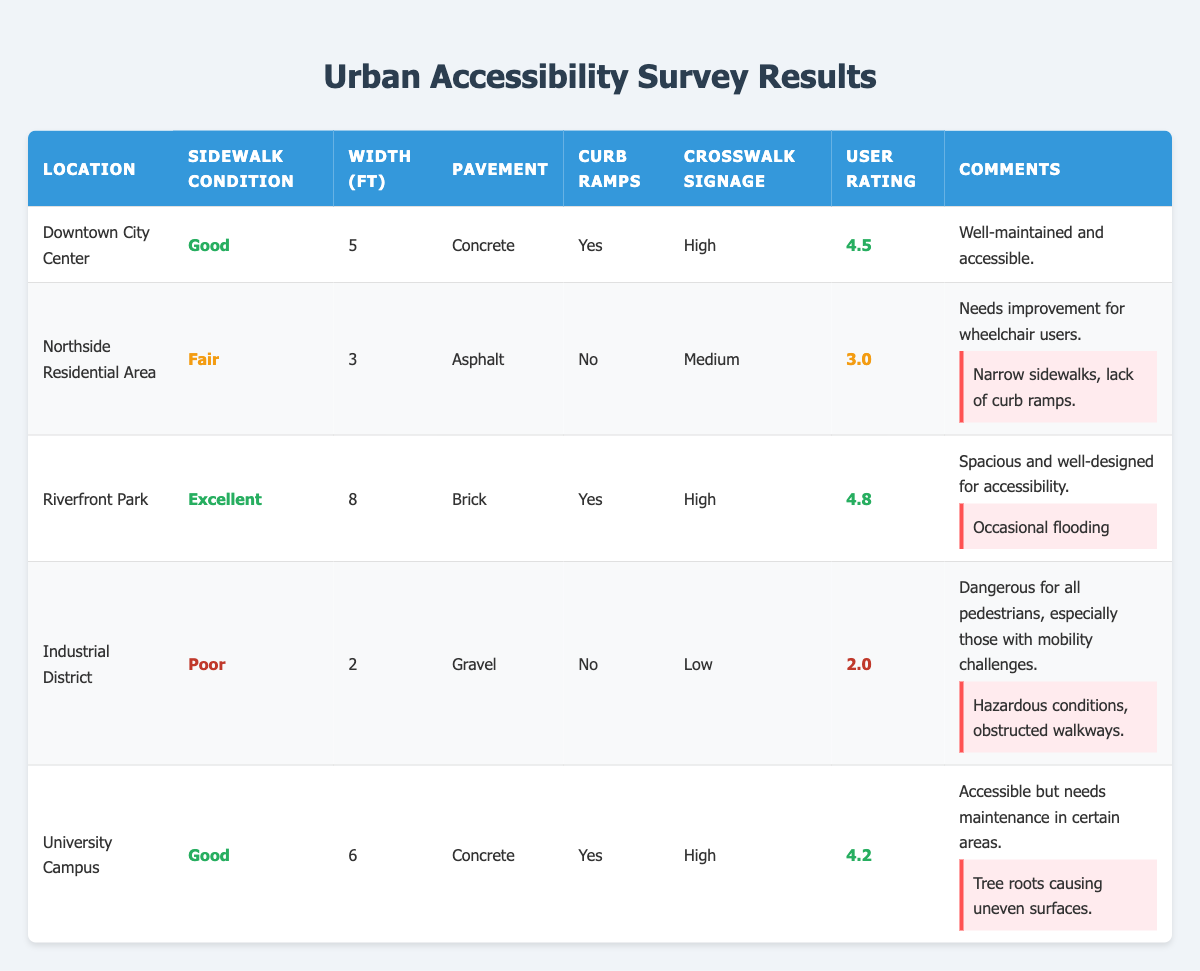What is the average user rating for the Riverfront Park? The user rating for Riverfront Park is listed in the table as 4.8. Since it is a single data point, the average user rating for that location is simply 4.8.
Answer: 4.8 Which location has the widest average sidewalk? The table shows the average widths for each location: Downtown City Center has 5 ft, Northside Residential Area has 3 ft, Riverfront Park has 8 ft, Industrial District has 2 ft, and University Campus has 6 ft. The maximum of these values is 8 ft at Riverfront Park.
Answer: Riverfront Park Is there a location that has curb ramps available and receives a user rating of 4.5 or higher? We need to look for locations with "Yes" in the curb ramps column and also a user rating of 4.5 or higher. Downtown City Center has a rating of 4.5 and Riverfront Park has 4.8. Hence, both these locations meet the criteria.
Answer: Yes What is the average width of sidewalks in locations with curb ramps available? The locations with curb ramps available are Downtown City Center (5 ft), Riverfront Park (8 ft), and University Campus (6 ft). To calculate the average: (5 + 8 + 6) / 3 = 19 / 3 = 6.33 ft.
Answer: 6.33 ft What are the reported issues in the Northside Residential Area? The Northside Residential Area has a noted issue of "Narrow sidewalks, lack of curb ramps" in the reported issues section of the table.
Answer: Narrow sidewalks, lack of curb ramps Which location has the lowest user rating, and what is it attributed to? By scanning the user ratings across all locations, Industrial District has the lowest rating of 2.0. The reported issues state it has "Hazardous conditions, obstructed walkways," which contribute to this low rating.
Answer: Industrial District; 2.0 